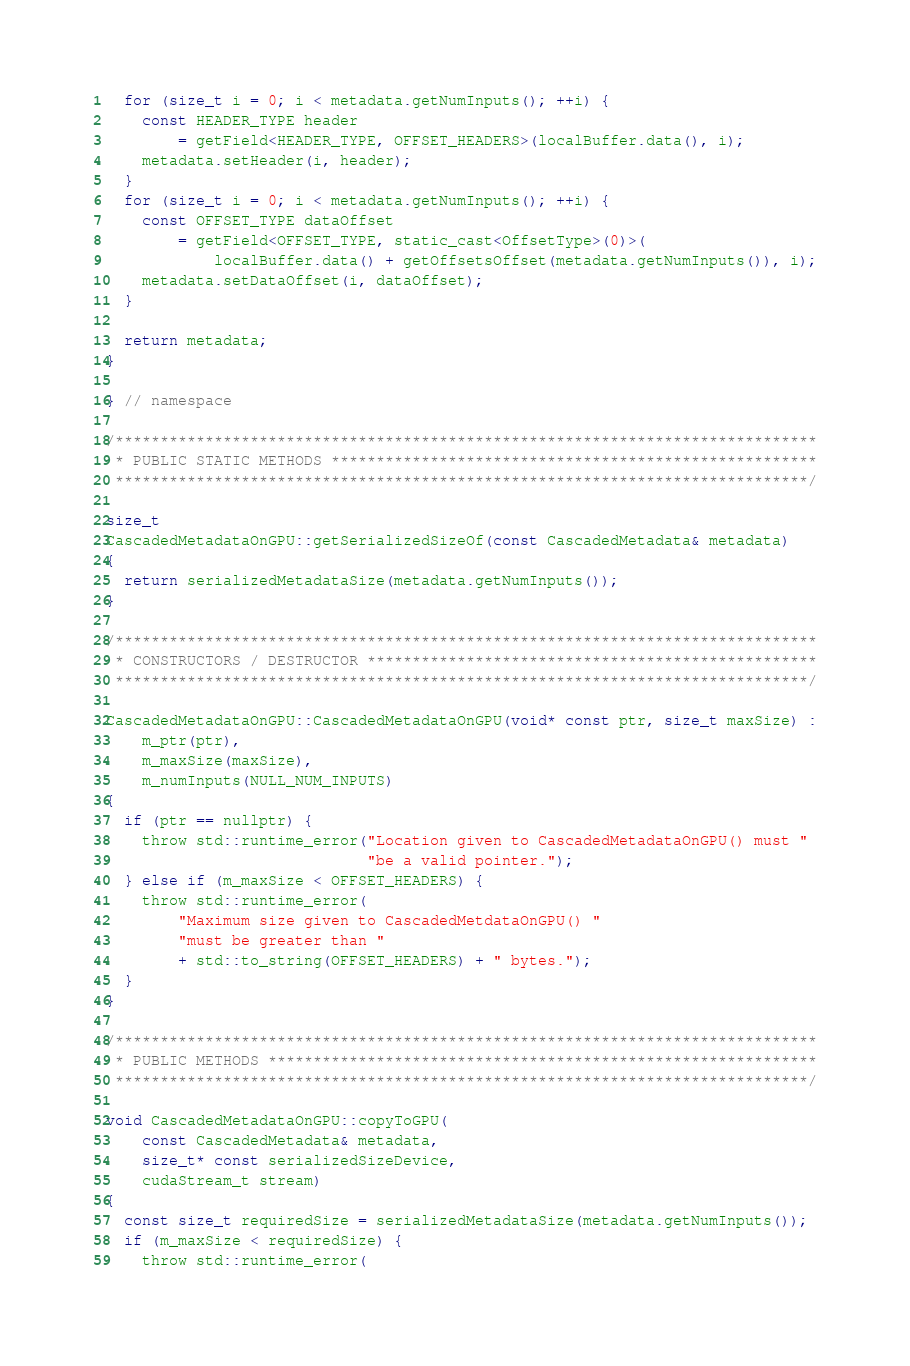Convert code to text. <code><loc_0><loc_0><loc_500><loc_500><_Cuda_>  for (size_t i = 0; i < metadata.getNumInputs(); ++i) {
    const HEADER_TYPE header
        = getField<HEADER_TYPE, OFFSET_HEADERS>(localBuffer.data(), i);
    metadata.setHeader(i, header);
  }
  for (size_t i = 0; i < metadata.getNumInputs(); ++i) {
    const OFFSET_TYPE dataOffset
        = getField<OFFSET_TYPE, static_cast<OffsetType>(0)>(
            localBuffer.data() + getOffsetsOffset(metadata.getNumInputs()), i);
    metadata.setDataOffset(i, dataOffset);
  }

  return metadata;
}

} // namespace

/******************************************************************************
 * PUBLIC STATIC METHODS ******************************************************
 *****************************************************************************/

size_t
CascadedMetadataOnGPU::getSerializedSizeOf(const CascadedMetadata& metadata)
{
  return serializedMetadataSize(metadata.getNumInputs());
}

/******************************************************************************
 * CONSTRUCTORS / DESTRUCTOR **************************************************
 *****************************************************************************/

CascadedMetadataOnGPU::CascadedMetadataOnGPU(void* const ptr, size_t maxSize) :
    m_ptr(ptr),
    m_maxSize(maxSize),
    m_numInputs(NULL_NUM_INPUTS)
{
  if (ptr == nullptr) {
    throw std::runtime_error("Location given to CascadedMetadataOnGPU() must "
                             "be a valid pointer.");
  } else if (m_maxSize < OFFSET_HEADERS) {
    throw std::runtime_error(
        "Maximum size given to CascadedMetdataOnGPU() "
        "must be greater than "
        + std::to_string(OFFSET_HEADERS) + " bytes.");
  }
}

/******************************************************************************
 * PUBLIC METHODS *************************************************************
 *****************************************************************************/

void CascadedMetadataOnGPU::copyToGPU(
    const CascadedMetadata& metadata,
    size_t* const serializedSizeDevice,
    cudaStream_t stream)
{
  const size_t requiredSize = serializedMetadataSize(metadata.getNumInputs());
  if (m_maxSize < requiredSize) {
    throw std::runtime_error(</code> 